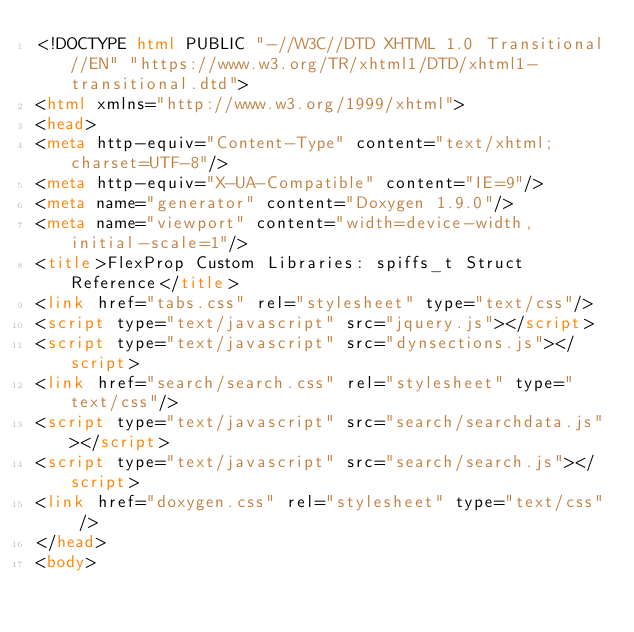Convert code to text. <code><loc_0><loc_0><loc_500><loc_500><_HTML_><!DOCTYPE html PUBLIC "-//W3C//DTD XHTML 1.0 Transitional//EN" "https://www.w3.org/TR/xhtml1/DTD/xhtml1-transitional.dtd">
<html xmlns="http://www.w3.org/1999/xhtml">
<head>
<meta http-equiv="Content-Type" content="text/xhtml;charset=UTF-8"/>
<meta http-equiv="X-UA-Compatible" content="IE=9"/>
<meta name="generator" content="Doxygen 1.9.0"/>
<meta name="viewport" content="width=device-width, initial-scale=1"/>
<title>FlexProp Custom Libraries: spiffs_t Struct Reference</title>
<link href="tabs.css" rel="stylesheet" type="text/css"/>
<script type="text/javascript" src="jquery.js"></script>
<script type="text/javascript" src="dynsections.js"></script>
<link href="search/search.css" rel="stylesheet" type="text/css"/>
<script type="text/javascript" src="search/searchdata.js"></script>
<script type="text/javascript" src="search/search.js"></script>
<link href="doxygen.css" rel="stylesheet" type="text/css" />
</head>
<body></code> 